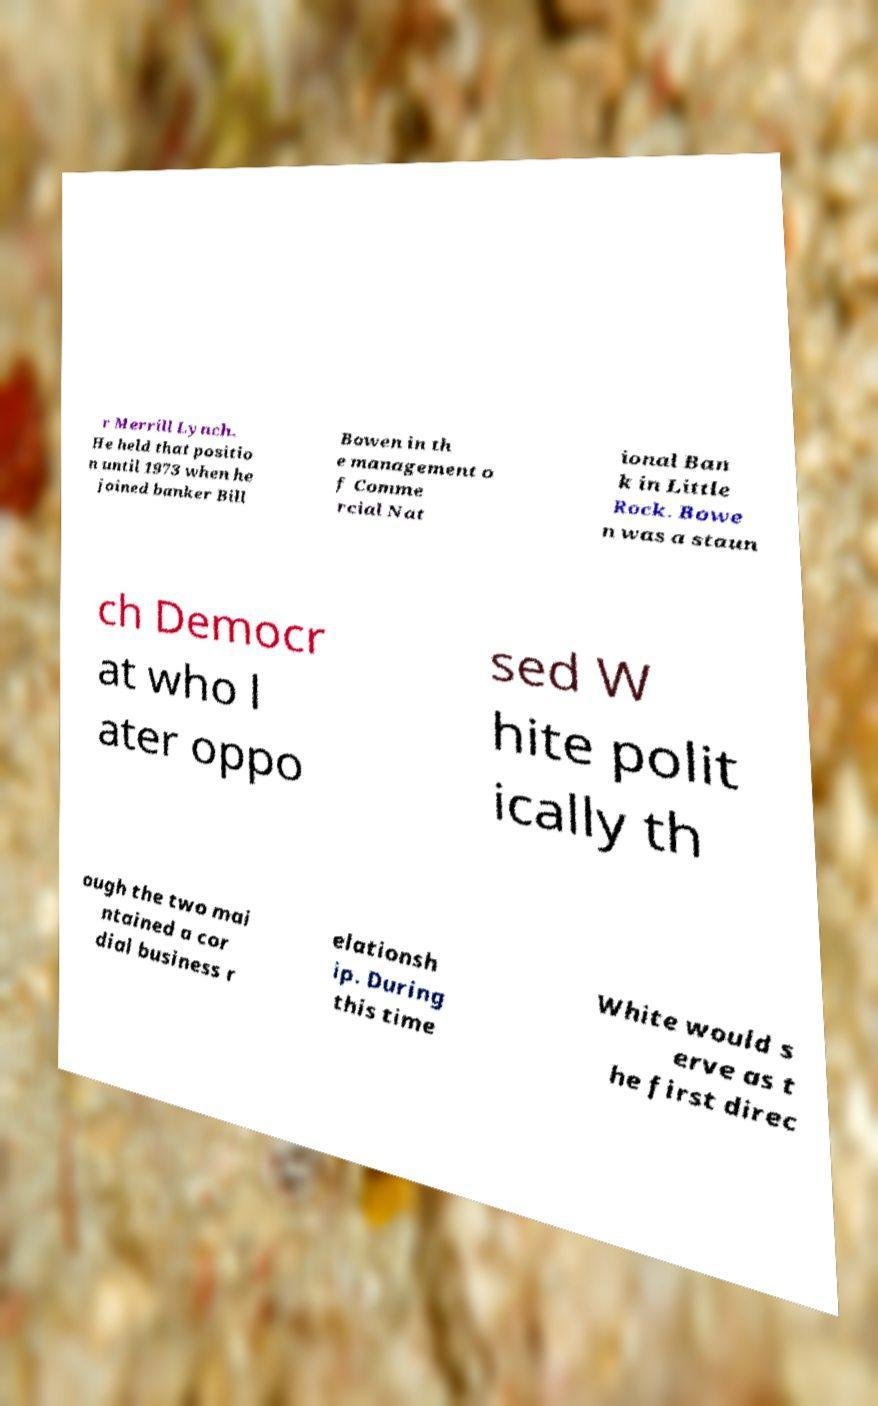There's text embedded in this image that I need extracted. Can you transcribe it verbatim? r Merrill Lynch. He held that positio n until 1973 when he joined banker Bill Bowen in th e management o f Comme rcial Nat ional Ban k in Little Rock. Bowe n was a staun ch Democr at who l ater oppo sed W hite polit ically th ough the two mai ntained a cor dial business r elationsh ip. During this time White would s erve as t he first direc 